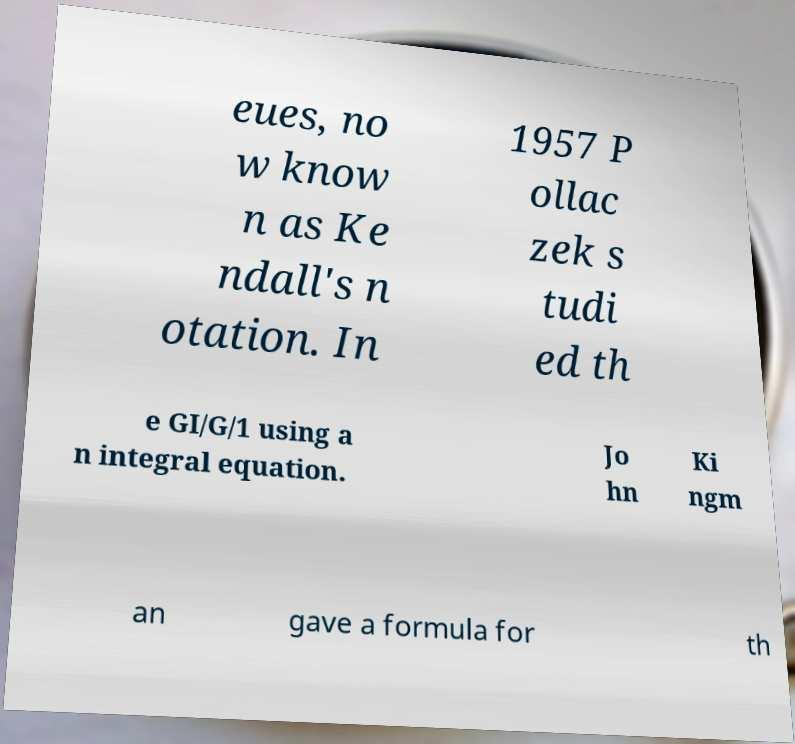Can you read and provide the text displayed in the image?This photo seems to have some interesting text. Can you extract and type it out for me? eues, no w know n as Ke ndall's n otation. In 1957 P ollac zek s tudi ed th e GI/G/1 using a n integral equation. Jo hn Ki ngm an gave a formula for th 